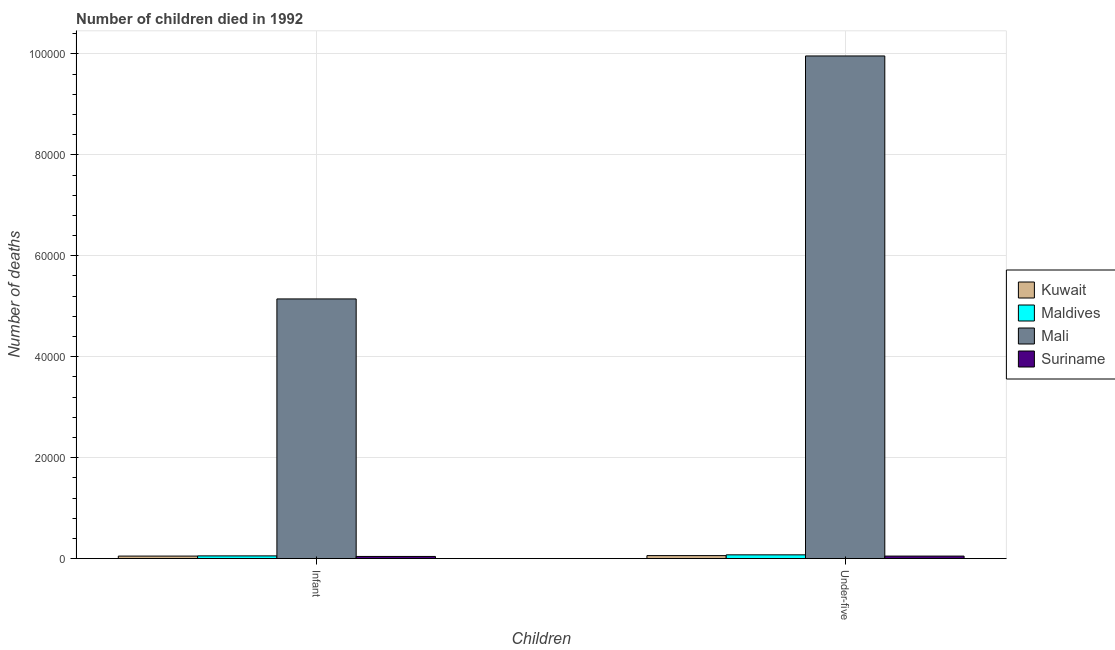Are the number of bars on each tick of the X-axis equal?
Offer a very short reply. Yes. How many bars are there on the 1st tick from the left?
Provide a succinct answer. 4. How many bars are there on the 1st tick from the right?
Keep it short and to the point. 4. What is the label of the 2nd group of bars from the left?
Your response must be concise. Under-five. What is the number of infant deaths in Suriname?
Provide a succinct answer. 421. Across all countries, what is the maximum number of infant deaths?
Ensure brevity in your answer.  5.15e+04. Across all countries, what is the minimum number of under-five deaths?
Provide a short and direct response. 492. In which country was the number of under-five deaths maximum?
Provide a short and direct response. Mali. In which country was the number of under-five deaths minimum?
Provide a short and direct response. Suriname. What is the total number of under-five deaths in the graph?
Provide a succinct answer. 1.01e+05. What is the difference between the number of under-five deaths in Mali and that in Kuwait?
Keep it short and to the point. 9.90e+04. What is the difference between the number of infant deaths in Kuwait and the number of under-five deaths in Suriname?
Your answer should be compact. -1. What is the average number of infant deaths per country?
Provide a short and direct response. 1.32e+04. What is the difference between the number of under-five deaths and number of infant deaths in Kuwait?
Provide a short and direct response. 96. In how many countries, is the number of under-five deaths greater than 32000 ?
Make the answer very short. 1. What is the ratio of the number of under-five deaths in Mali to that in Maldives?
Keep it short and to the point. 134.78. In how many countries, is the number of under-five deaths greater than the average number of under-five deaths taken over all countries?
Your answer should be very brief. 1. What does the 3rd bar from the left in Infant represents?
Your answer should be compact. Mali. What does the 2nd bar from the right in Under-five represents?
Offer a terse response. Mali. Are all the bars in the graph horizontal?
Provide a short and direct response. No. What is the difference between two consecutive major ticks on the Y-axis?
Provide a succinct answer. 2.00e+04. Does the graph contain any zero values?
Offer a very short reply. No. Does the graph contain grids?
Offer a terse response. Yes. Where does the legend appear in the graph?
Your answer should be compact. Center right. How many legend labels are there?
Ensure brevity in your answer.  4. What is the title of the graph?
Offer a terse response. Number of children died in 1992. What is the label or title of the X-axis?
Offer a terse response. Children. What is the label or title of the Y-axis?
Your answer should be compact. Number of deaths. What is the Number of deaths in Kuwait in Infant?
Make the answer very short. 491. What is the Number of deaths in Maldives in Infant?
Provide a short and direct response. 531. What is the Number of deaths of Mali in Infant?
Ensure brevity in your answer.  5.15e+04. What is the Number of deaths of Suriname in Infant?
Give a very brief answer. 421. What is the Number of deaths of Kuwait in Under-five?
Your answer should be very brief. 587. What is the Number of deaths in Maldives in Under-five?
Offer a very short reply. 739. What is the Number of deaths in Mali in Under-five?
Provide a succinct answer. 9.96e+04. What is the Number of deaths of Suriname in Under-five?
Offer a very short reply. 492. Across all Children, what is the maximum Number of deaths in Kuwait?
Your answer should be very brief. 587. Across all Children, what is the maximum Number of deaths in Maldives?
Provide a short and direct response. 739. Across all Children, what is the maximum Number of deaths in Mali?
Make the answer very short. 9.96e+04. Across all Children, what is the maximum Number of deaths of Suriname?
Your answer should be compact. 492. Across all Children, what is the minimum Number of deaths of Kuwait?
Ensure brevity in your answer.  491. Across all Children, what is the minimum Number of deaths in Maldives?
Your response must be concise. 531. Across all Children, what is the minimum Number of deaths of Mali?
Give a very brief answer. 5.15e+04. Across all Children, what is the minimum Number of deaths of Suriname?
Offer a very short reply. 421. What is the total Number of deaths of Kuwait in the graph?
Provide a short and direct response. 1078. What is the total Number of deaths in Maldives in the graph?
Your answer should be very brief. 1270. What is the total Number of deaths of Mali in the graph?
Provide a short and direct response. 1.51e+05. What is the total Number of deaths of Suriname in the graph?
Provide a succinct answer. 913. What is the difference between the Number of deaths of Kuwait in Infant and that in Under-five?
Your answer should be very brief. -96. What is the difference between the Number of deaths of Maldives in Infant and that in Under-five?
Your answer should be compact. -208. What is the difference between the Number of deaths in Mali in Infant and that in Under-five?
Your answer should be very brief. -4.82e+04. What is the difference between the Number of deaths of Suriname in Infant and that in Under-five?
Your response must be concise. -71. What is the difference between the Number of deaths in Kuwait in Infant and the Number of deaths in Maldives in Under-five?
Offer a very short reply. -248. What is the difference between the Number of deaths in Kuwait in Infant and the Number of deaths in Mali in Under-five?
Provide a short and direct response. -9.91e+04. What is the difference between the Number of deaths of Maldives in Infant and the Number of deaths of Mali in Under-five?
Provide a succinct answer. -9.91e+04. What is the difference between the Number of deaths of Maldives in Infant and the Number of deaths of Suriname in Under-five?
Offer a terse response. 39. What is the difference between the Number of deaths of Mali in Infant and the Number of deaths of Suriname in Under-five?
Your answer should be compact. 5.10e+04. What is the average Number of deaths in Kuwait per Children?
Keep it short and to the point. 539. What is the average Number of deaths in Maldives per Children?
Your answer should be compact. 635. What is the average Number of deaths in Mali per Children?
Offer a very short reply. 7.55e+04. What is the average Number of deaths in Suriname per Children?
Offer a terse response. 456.5. What is the difference between the Number of deaths of Kuwait and Number of deaths of Mali in Infant?
Offer a very short reply. -5.10e+04. What is the difference between the Number of deaths in Kuwait and Number of deaths in Suriname in Infant?
Make the answer very short. 70. What is the difference between the Number of deaths in Maldives and Number of deaths in Mali in Infant?
Give a very brief answer. -5.09e+04. What is the difference between the Number of deaths of Maldives and Number of deaths of Suriname in Infant?
Provide a succinct answer. 110. What is the difference between the Number of deaths of Mali and Number of deaths of Suriname in Infant?
Provide a short and direct response. 5.10e+04. What is the difference between the Number of deaths in Kuwait and Number of deaths in Maldives in Under-five?
Provide a succinct answer. -152. What is the difference between the Number of deaths of Kuwait and Number of deaths of Mali in Under-five?
Keep it short and to the point. -9.90e+04. What is the difference between the Number of deaths in Maldives and Number of deaths in Mali in Under-five?
Your answer should be very brief. -9.89e+04. What is the difference between the Number of deaths of Maldives and Number of deaths of Suriname in Under-five?
Your response must be concise. 247. What is the difference between the Number of deaths in Mali and Number of deaths in Suriname in Under-five?
Your response must be concise. 9.91e+04. What is the ratio of the Number of deaths of Kuwait in Infant to that in Under-five?
Offer a very short reply. 0.84. What is the ratio of the Number of deaths of Maldives in Infant to that in Under-five?
Offer a terse response. 0.72. What is the ratio of the Number of deaths in Mali in Infant to that in Under-five?
Provide a succinct answer. 0.52. What is the ratio of the Number of deaths in Suriname in Infant to that in Under-five?
Offer a very short reply. 0.86. What is the difference between the highest and the second highest Number of deaths in Kuwait?
Provide a succinct answer. 96. What is the difference between the highest and the second highest Number of deaths in Maldives?
Provide a succinct answer. 208. What is the difference between the highest and the second highest Number of deaths in Mali?
Keep it short and to the point. 4.82e+04. What is the difference between the highest and the second highest Number of deaths in Suriname?
Provide a succinct answer. 71. What is the difference between the highest and the lowest Number of deaths in Kuwait?
Ensure brevity in your answer.  96. What is the difference between the highest and the lowest Number of deaths in Maldives?
Offer a very short reply. 208. What is the difference between the highest and the lowest Number of deaths of Mali?
Your answer should be very brief. 4.82e+04. 